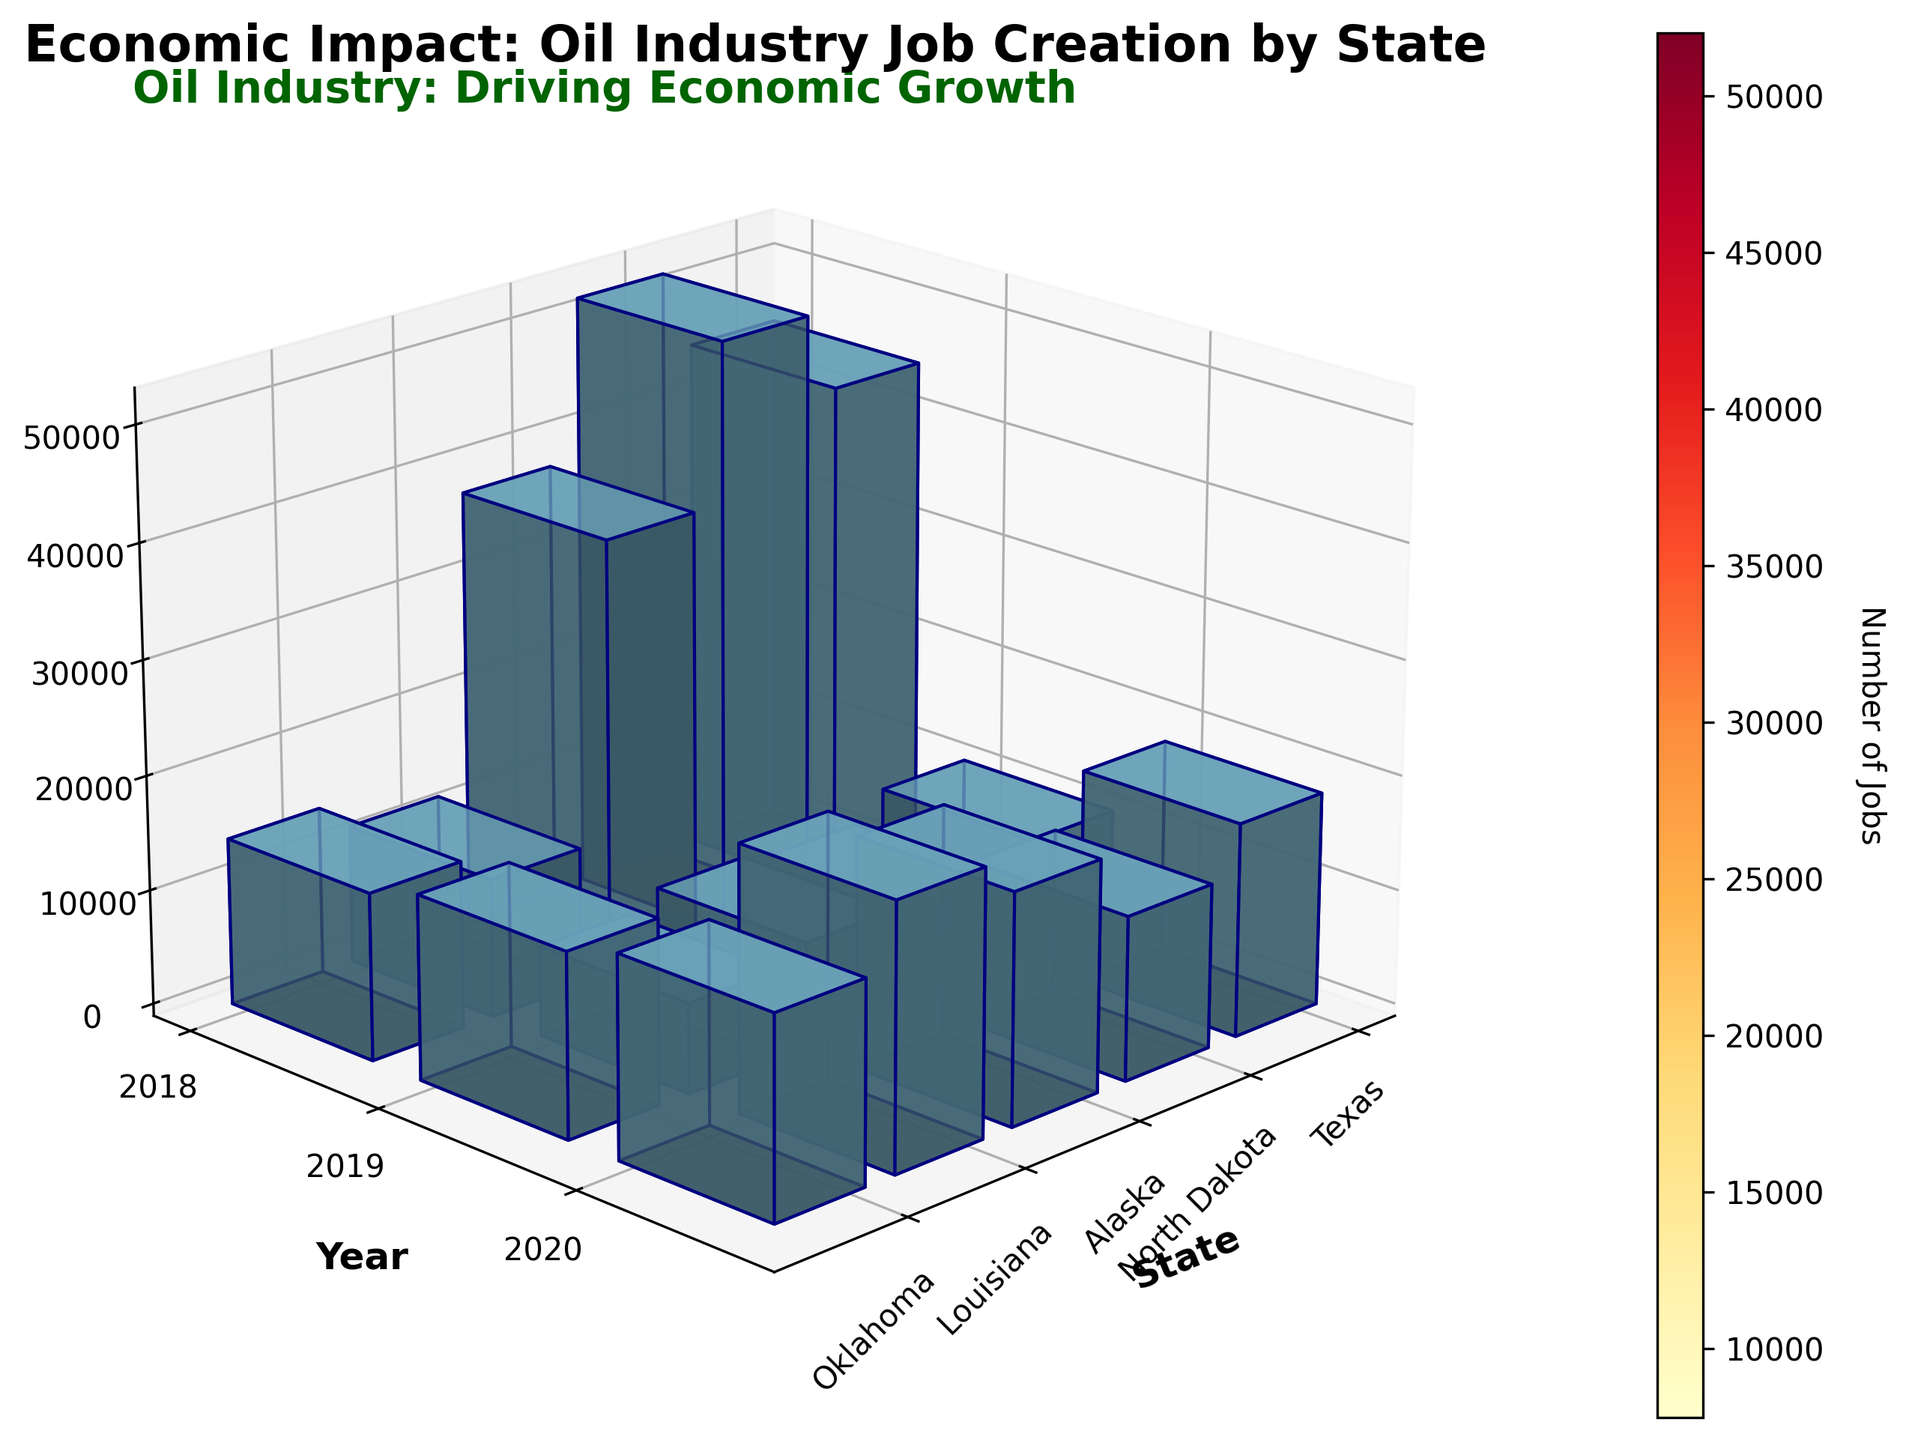How many jobs were created in Texas in 2020? Examine the bar corresponding to Texas for the year 2020 and read the height value of the bar indicating the number of jobs created.
Answer: 38,000 Which state had the highest number of jobs created in 2019? Compare the heights of the bars in 2019 for each state and identify which is the tallest. Texas has the highest bar.
Answer: Texas What is the combined total number of jobs created in Oklahoma over all three years? Sum the number of jobs created in Oklahoma for 2018, 2019, and 2020 (20,000 + 23,000 + 17,500).
Answer: 60,500 How does the number of jobs created in North Dakota in 2018 compare to 2019? Look at the bars for North Dakota in 2018 and 2019. The bar in 2019 is higher than in 2018, indicating more jobs were created in 2019.
Answer: Fewer in 2018 What is the average number of jobs created across all five states in 2020? Sum the job creation numbers for all states in 2020 (38,000+10,800+7,800+14,200+17,500) and divide by 5 (88,300 / 5).
Answer: 17,660 Which year had the lowest job creation in Louisiana? Compare the heights of bars for Louisiana across 2018, 2019, and 2020. The lowest bar is in 2020.
Answer: 2020 By what percentage did job creation in Alaska decrease from 2019 to 2020? Calculate the difference in job creation from 2019 to 2020 in Alaska (9,200 - 7,800 = 1,400). Divide this difference by the number of jobs created in 2019 and multiply by 100. (1,400 / 9,200 * 100).
Answer: 15.2% What is the total number of jobs created in 2018 across all states? Add the number of jobs created in each state for 2018 (45,000 + 12,000 + 8,500 + 16,000 + 20,000).
Answer: 101,500 Which state showed the biggest drop in job creation from 2019 to 2020? Calculate the drop in job creation for each state between 2019 to 2020 and find the largest value. Texas showed the biggest drop (52,000 - 38,000 = 14,000).
Answer: Texas 